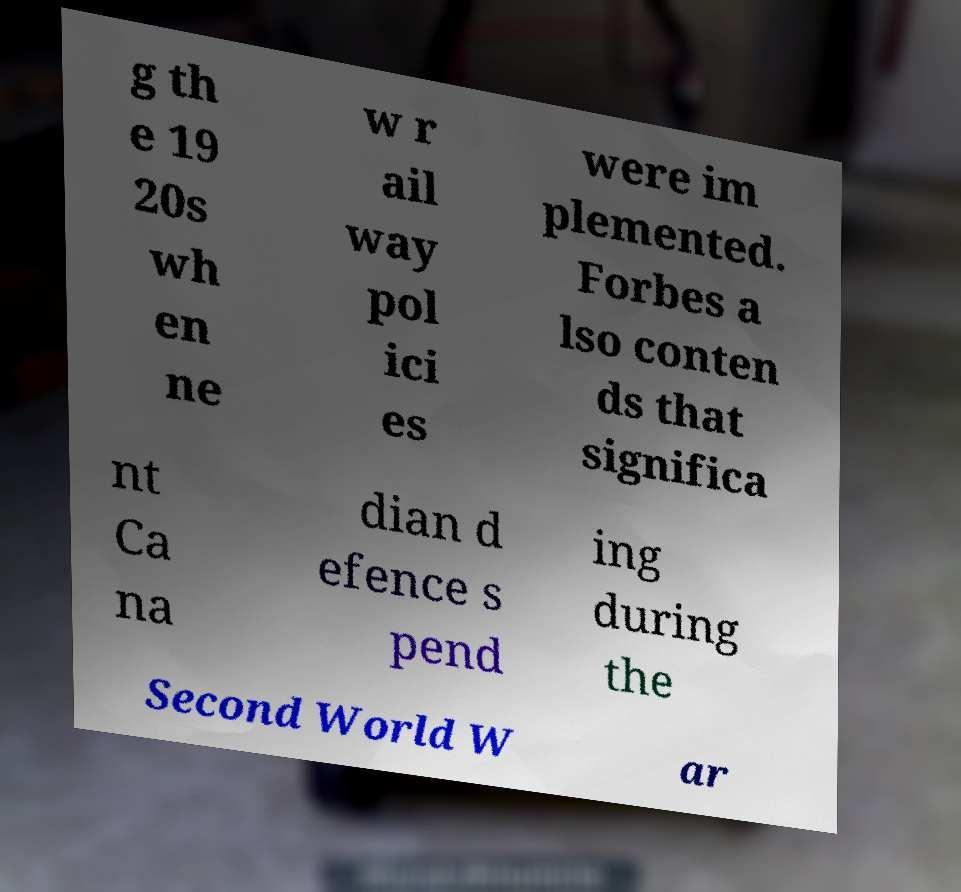Can you read and provide the text displayed in the image?This photo seems to have some interesting text. Can you extract and type it out for me? g th e 19 20s wh en ne w r ail way pol ici es were im plemented. Forbes a lso conten ds that significa nt Ca na dian d efence s pend ing during the Second World W ar 